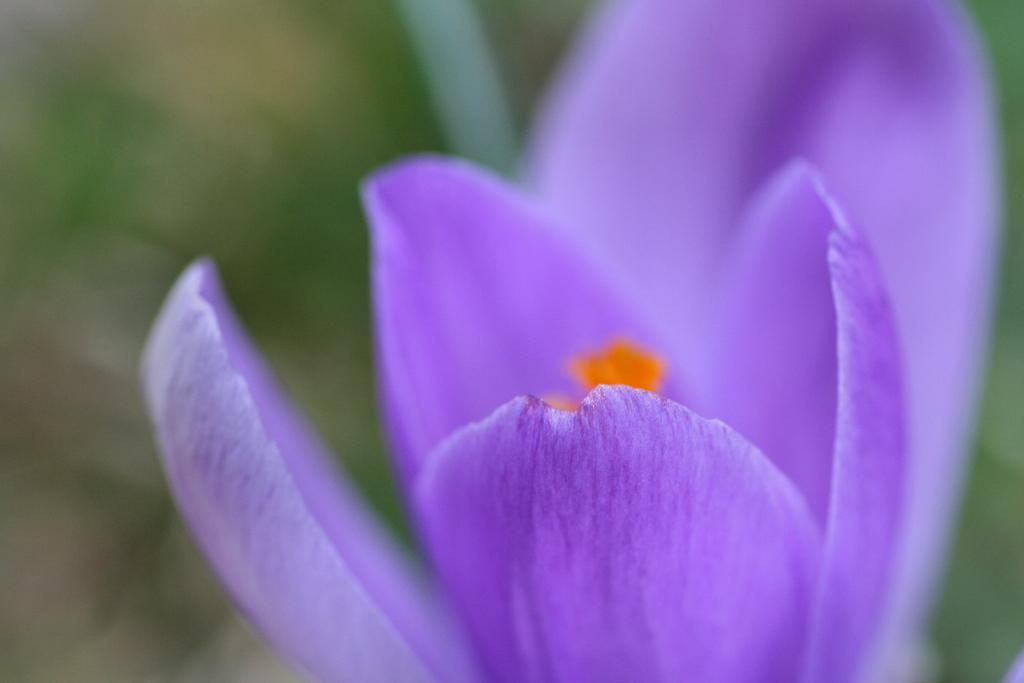What is the main subject in the foreground of the image? There is a purple color flower in the foreground of the image. How would you describe the background of the image? The background of the image is blurry. Can you identify any other plants or vegetation in the image? It is mentioned that there might be a plant in the background of the image. What type of behavior does the salt exhibit in the image? There is no salt present in the image, so its behavior cannot be observed or described. 